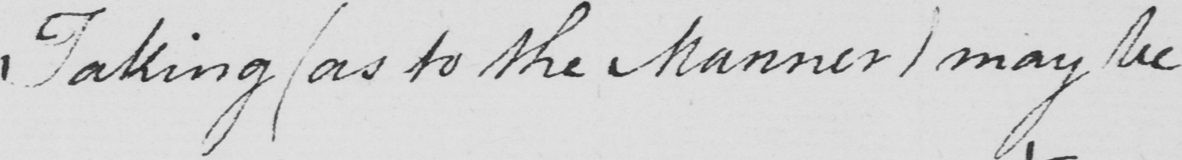What is written in this line of handwriting? Taking  ( as to the Manner )  may be 